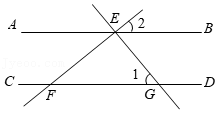What can we infer about the properties of the lines and angles shown in this image? From the image, we can infer that lines AB and CD are parallel, as indicated by their configuration and common geometric conventions. Line EF, which intersects lines AB and CD, serves as a transversal. As a result, this setup allows exploration of several properties of parallel lines and transversals such as corresponding angles, alternate interior angles, and consecutive interior angles. These geometrical properties form the basis for many proofs and theorems in Euclidean geometry relevant to parallel lines. 